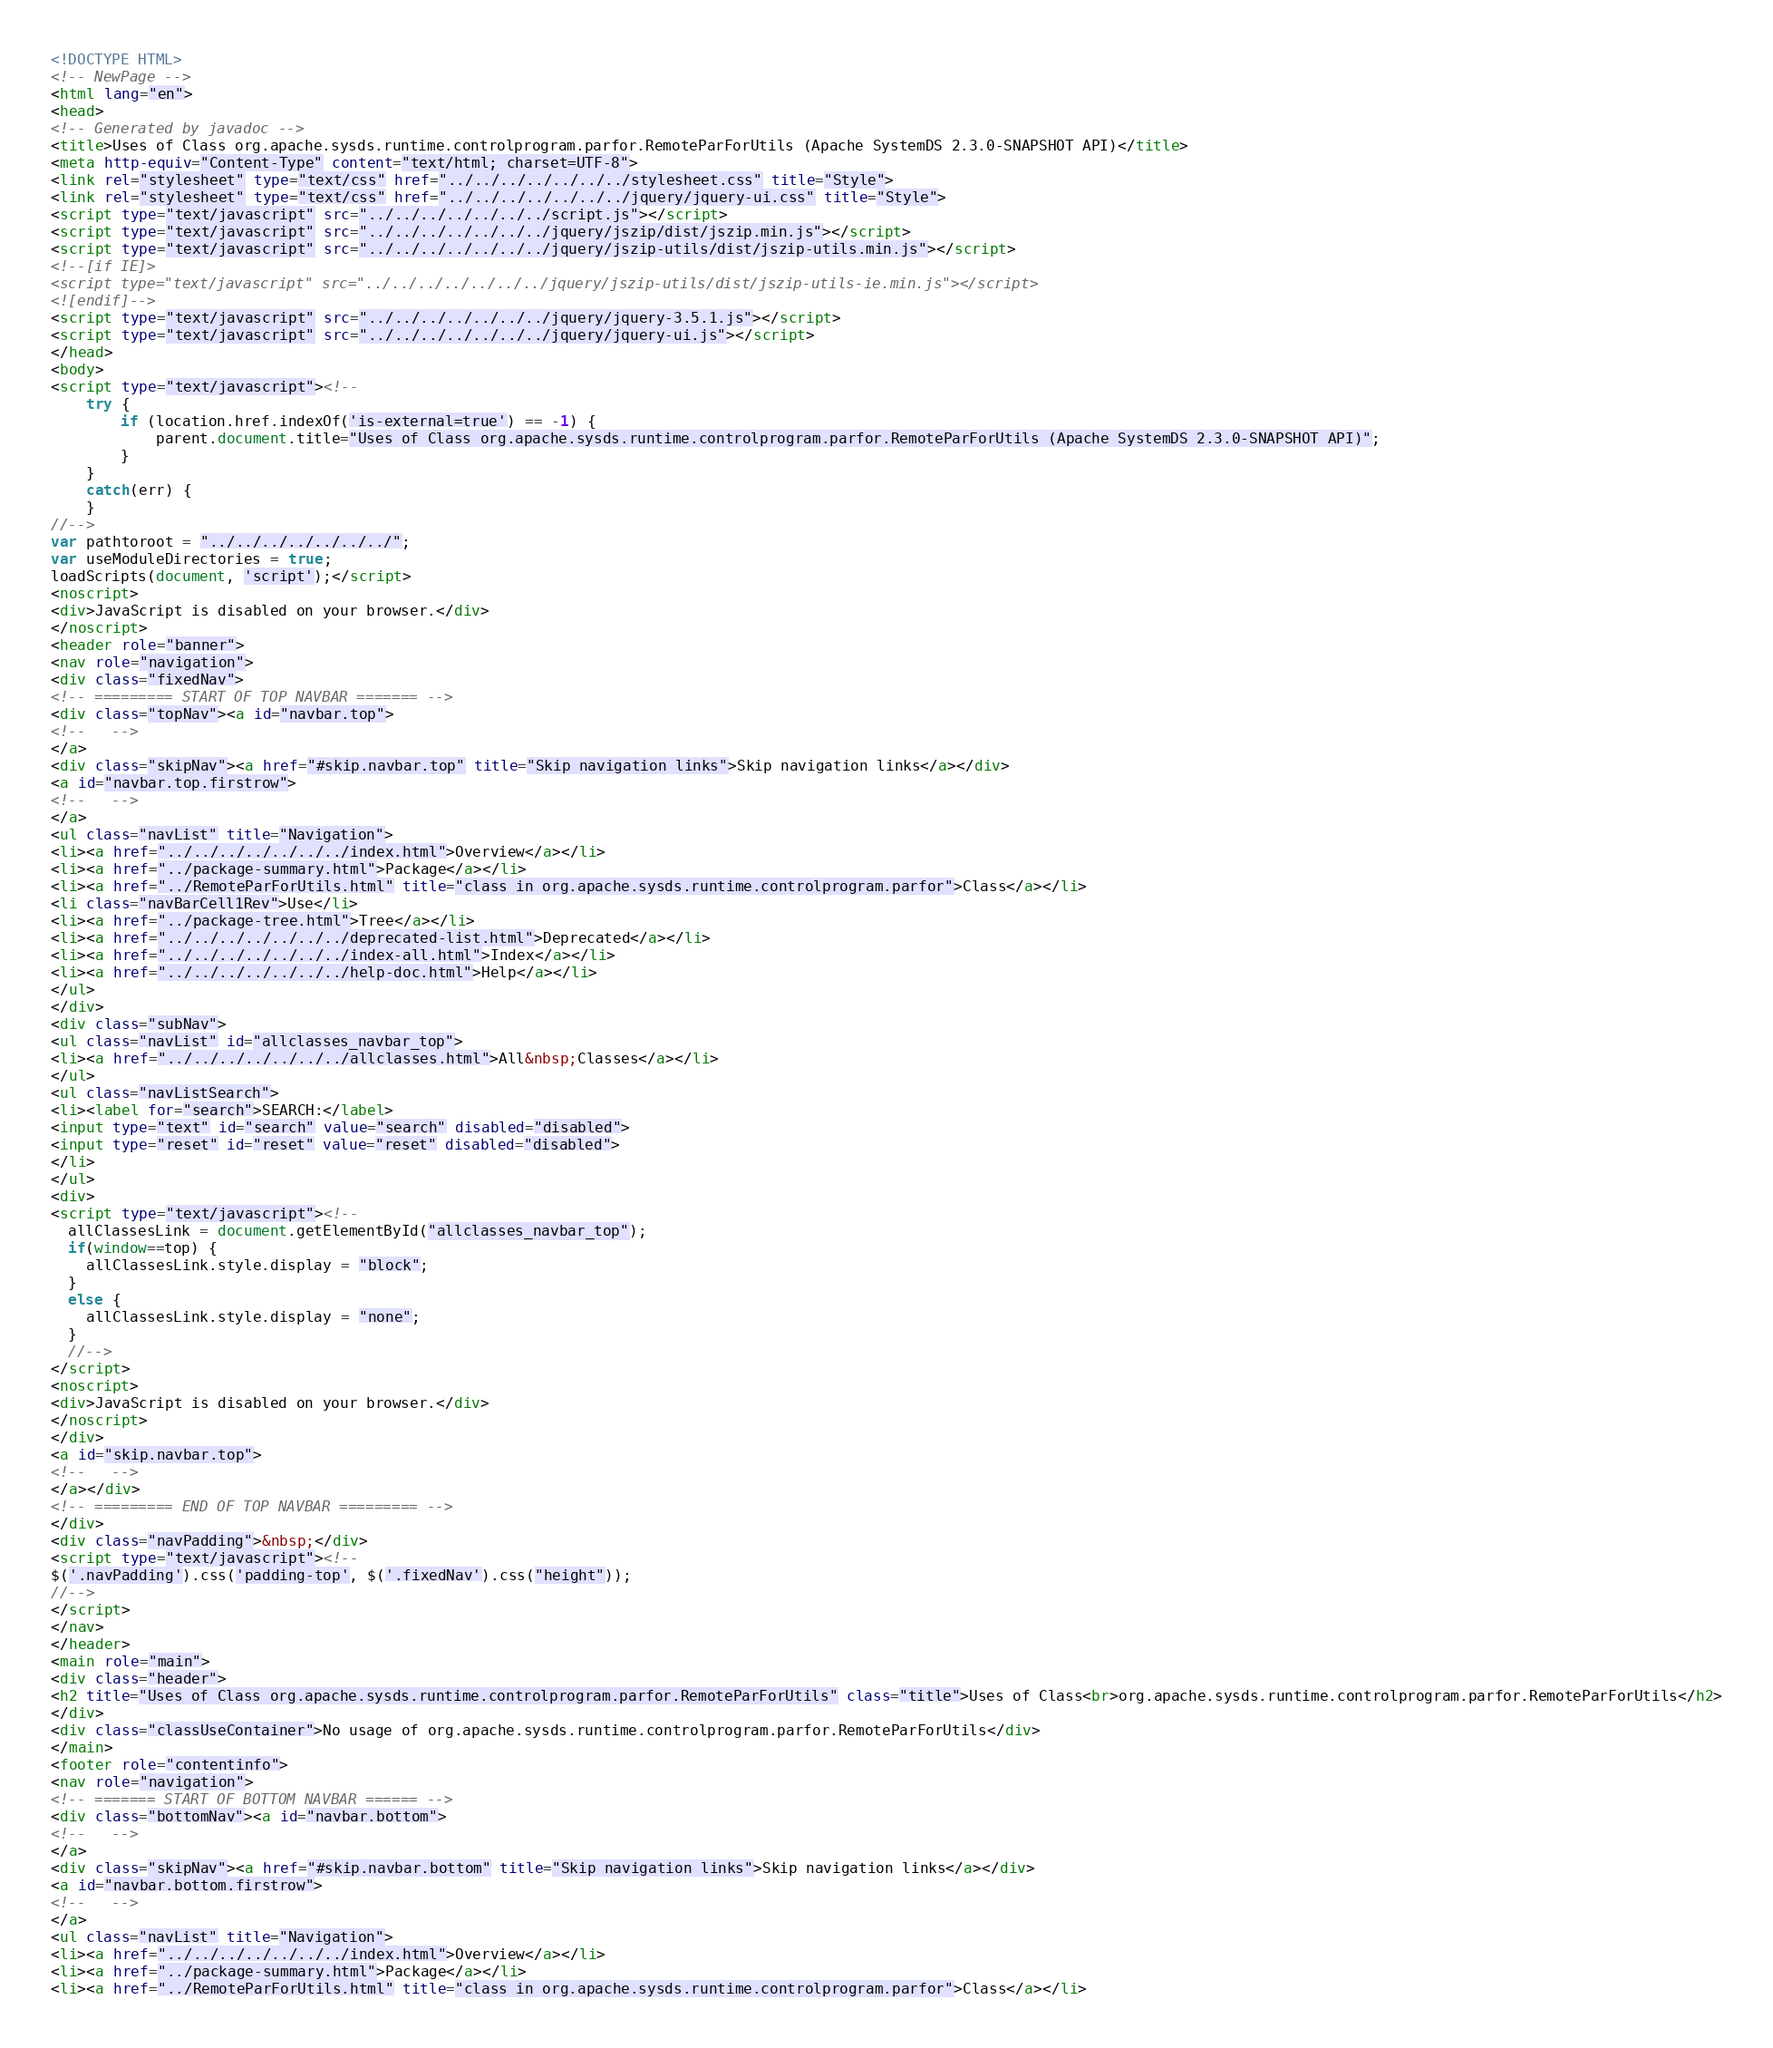Convert code to text. <code><loc_0><loc_0><loc_500><loc_500><_HTML_><!DOCTYPE HTML>
<!-- NewPage -->
<html lang="en">
<head>
<!-- Generated by javadoc -->
<title>Uses of Class org.apache.sysds.runtime.controlprogram.parfor.RemoteParForUtils (Apache SystemDS 2.3.0-SNAPSHOT API)</title>
<meta http-equiv="Content-Type" content="text/html; charset=UTF-8">
<link rel="stylesheet" type="text/css" href="../../../../../../../stylesheet.css" title="Style">
<link rel="stylesheet" type="text/css" href="../../../../../../../jquery/jquery-ui.css" title="Style">
<script type="text/javascript" src="../../../../../../../script.js"></script>
<script type="text/javascript" src="../../../../../../../jquery/jszip/dist/jszip.min.js"></script>
<script type="text/javascript" src="../../../../../../../jquery/jszip-utils/dist/jszip-utils.min.js"></script>
<!--[if IE]>
<script type="text/javascript" src="../../../../../../../jquery/jszip-utils/dist/jszip-utils-ie.min.js"></script>
<![endif]-->
<script type="text/javascript" src="../../../../../../../jquery/jquery-3.5.1.js"></script>
<script type="text/javascript" src="../../../../../../../jquery/jquery-ui.js"></script>
</head>
<body>
<script type="text/javascript"><!--
    try {
        if (location.href.indexOf('is-external=true') == -1) {
            parent.document.title="Uses of Class org.apache.sysds.runtime.controlprogram.parfor.RemoteParForUtils (Apache SystemDS 2.3.0-SNAPSHOT API)";
        }
    }
    catch(err) {
    }
//-->
var pathtoroot = "../../../../../../../";
var useModuleDirectories = true;
loadScripts(document, 'script');</script>
<noscript>
<div>JavaScript is disabled on your browser.</div>
</noscript>
<header role="banner">
<nav role="navigation">
<div class="fixedNav">
<!-- ========= START OF TOP NAVBAR ======= -->
<div class="topNav"><a id="navbar.top">
<!--   -->
</a>
<div class="skipNav"><a href="#skip.navbar.top" title="Skip navigation links">Skip navigation links</a></div>
<a id="navbar.top.firstrow">
<!--   -->
</a>
<ul class="navList" title="Navigation">
<li><a href="../../../../../../../index.html">Overview</a></li>
<li><a href="../package-summary.html">Package</a></li>
<li><a href="../RemoteParForUtils.html" title="class in org.apache.sysds.runtime.controlprogram.parfor">Class</a></li>
<li class="navBarCell1Rev">Use</li>
<li><a href="../package-tree.html">Tree</a></li>
<li><a href="../../../../../../../deprecated-list.html">Deprecated</a></li>
<li><a href="../../../../../../../index-all.html">Index</a></li>
<li><a href="../../../../../../../help-doc.html">Help</a></li>
</ul>
</div>
<div class="subNav">
<ul class="navList" id="allclasses_navbar_top">
<li><a href="../../../../../../../allclasses.html">All&nbsp;Classes</a></li>
</ul>
<ul class="navListSearch">
<li><label for="search">SEARCH:</label>
<input type="text" id="search" value="search" disabled="disabled">
<input type="reset" id="reset" value="reset" disabled="disabled">
</li>
</ul>
<div>
<script type="text/javascript"><!--
  allClassesLink = document.getElementById("allclasses_navbar_top");
  if(window==top) {
    allClassesLink.style.display = "block";
  }
  else {
    allClassesLink.style.display = "none";
  }
  //-->
</script>
<noscript>
<div>JavaScript is disabled on your browser.</div>
</noscript>
</div>
<a id="skip.navbar.top">
<!--   -->
</a></div>
<!-- ========= END OF TOP NAVBAR ========= -->
</div>
<div class="navPadding">&nbsp;</div>
<script type="text/javascript"><!--
$('.navPadding').css('padding-top', $('.fixedNav').css("height"));
//-->
</script>
</nav>
</header>
<main role="main">
<div class="header">
<h2 title="Uses of Class org.apache.sysds.runtime.controlprogram.parfor.RemoteParForUtils" class="title">Uses of Class<br>org.apache.sysds.runtime.controlprogram.parfor.RemoteParForUtils</h2>
</div>
<div class="classUseContainer">No usage of org.apache.sysds.runtime.controlprogram.parfor.RemoteParForUtils</div>
</main>
<footer role="contentinfo">
<nav role="navigation">
<!-- ======= START OF BOTTOM NAVBAR ====== -->
<div class="bottomNav"><a id="navbar.bottom">
<!--   -->
</a>
<div class="skipNav"><a href="#skip.navbar.bottom" title="Skip navigation links">Skip navigation links</a></div>
<a id="navbar.bottom.firstrow">
<!--   -->
</a>
<ul class="navList" title="Navigation">
<li><a href="../../../../../../../index.html">Overview</a></li>
<li><a href="../package-summary.html">Package</a></li>
<li><a href="../RemoteParForUtils.html" title="class in org.apache.sysds.runtime.controlprogram.parfor">Class</a></li></code> 